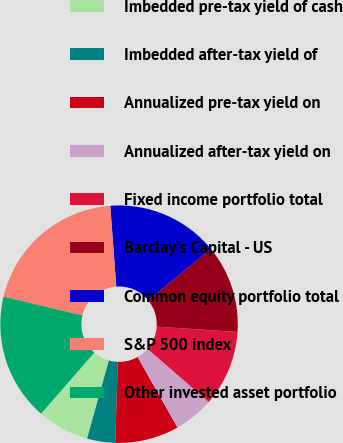Convert chart to OTSL. <chart><loc_0><loc_0><loc_500><loc_500><pie_chart><fcel>Imbedded pre-tax yield of cash<fcel>Imbedded after-tax yield of<fcel>Annualized pre-tax yield on<fcel>Annualized after-tax yield on<fcel>Fixed income portfolio total<fcel>Barclay's Capital - US<fcel>Common equity portfolio total<fcel>S&P 500 index<fcel>Other invested asset portfolio<nl><fcel>7.07%<fcel>3.82%<fcel>8.7%<fcel>5.44%<fcel>10.33%<fcel>11.96%<fcel>15.26%<fcel>20.1%<fcel>17.31%<nl></chart> 